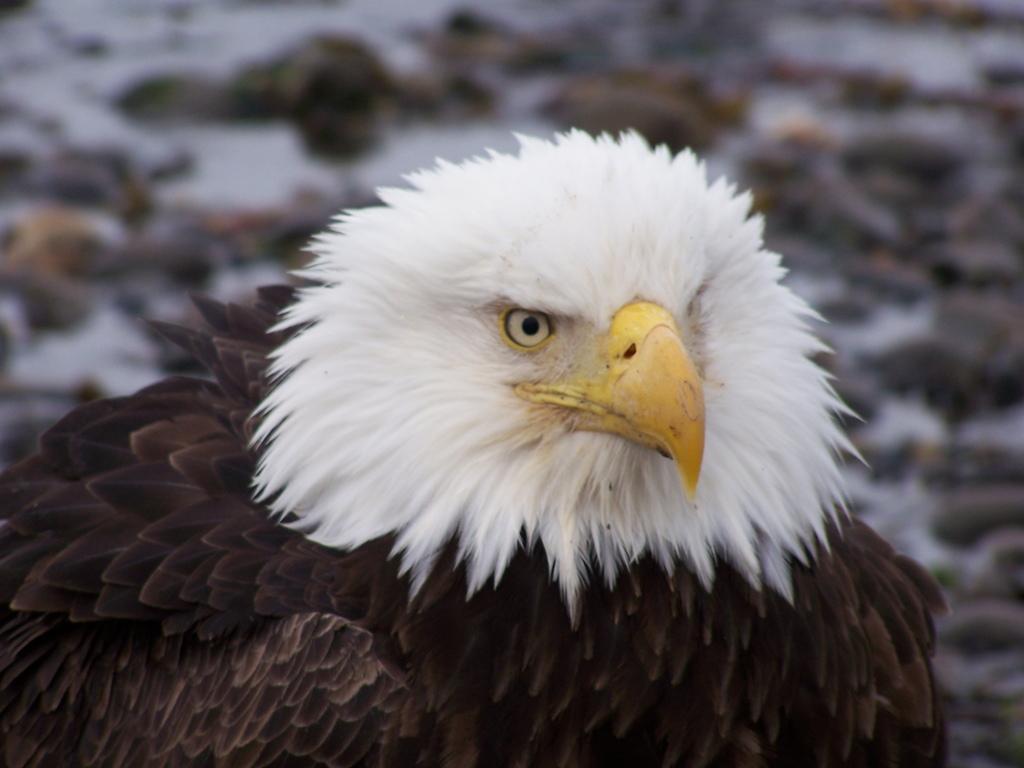Please provide a concise description of this image. In this picture I can see an eagle, and there is blur background. 